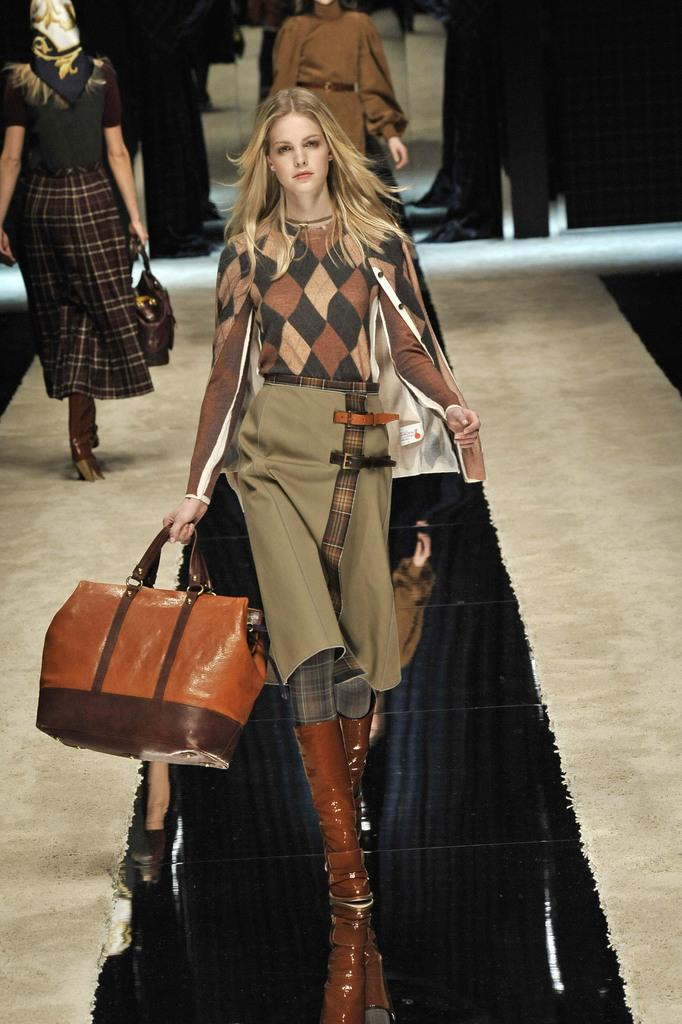What is the woman in the image doing? The woman is standing on a stage in the image. What is the woman holding in the image? The woman is holding a bag. Are there any other people visible in the image? Yes, there are multiple women standing at the back of the stage. What type of scissors can be seen being used by the woman on the stage? There are no scissors visible in the image; the woman is holding a bag. Can you tell me how many buckets are present on the stage? There are no buckets present in the image; the focus is on the woman and the multiple women standing at the back of the stage. 